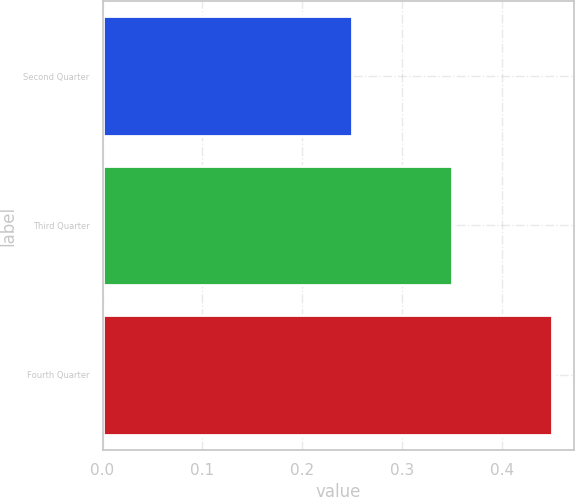Convert chart to OTSL. <chart><loc_0><loc_0><loc_500><loc_500><bar_chart><fcel>Second Quarter<fcel>Third Quarter<fcel>Fourth Quarter<nl><fcel>0.25<fcel>0.35<fcel>0.45<nl></chart> 